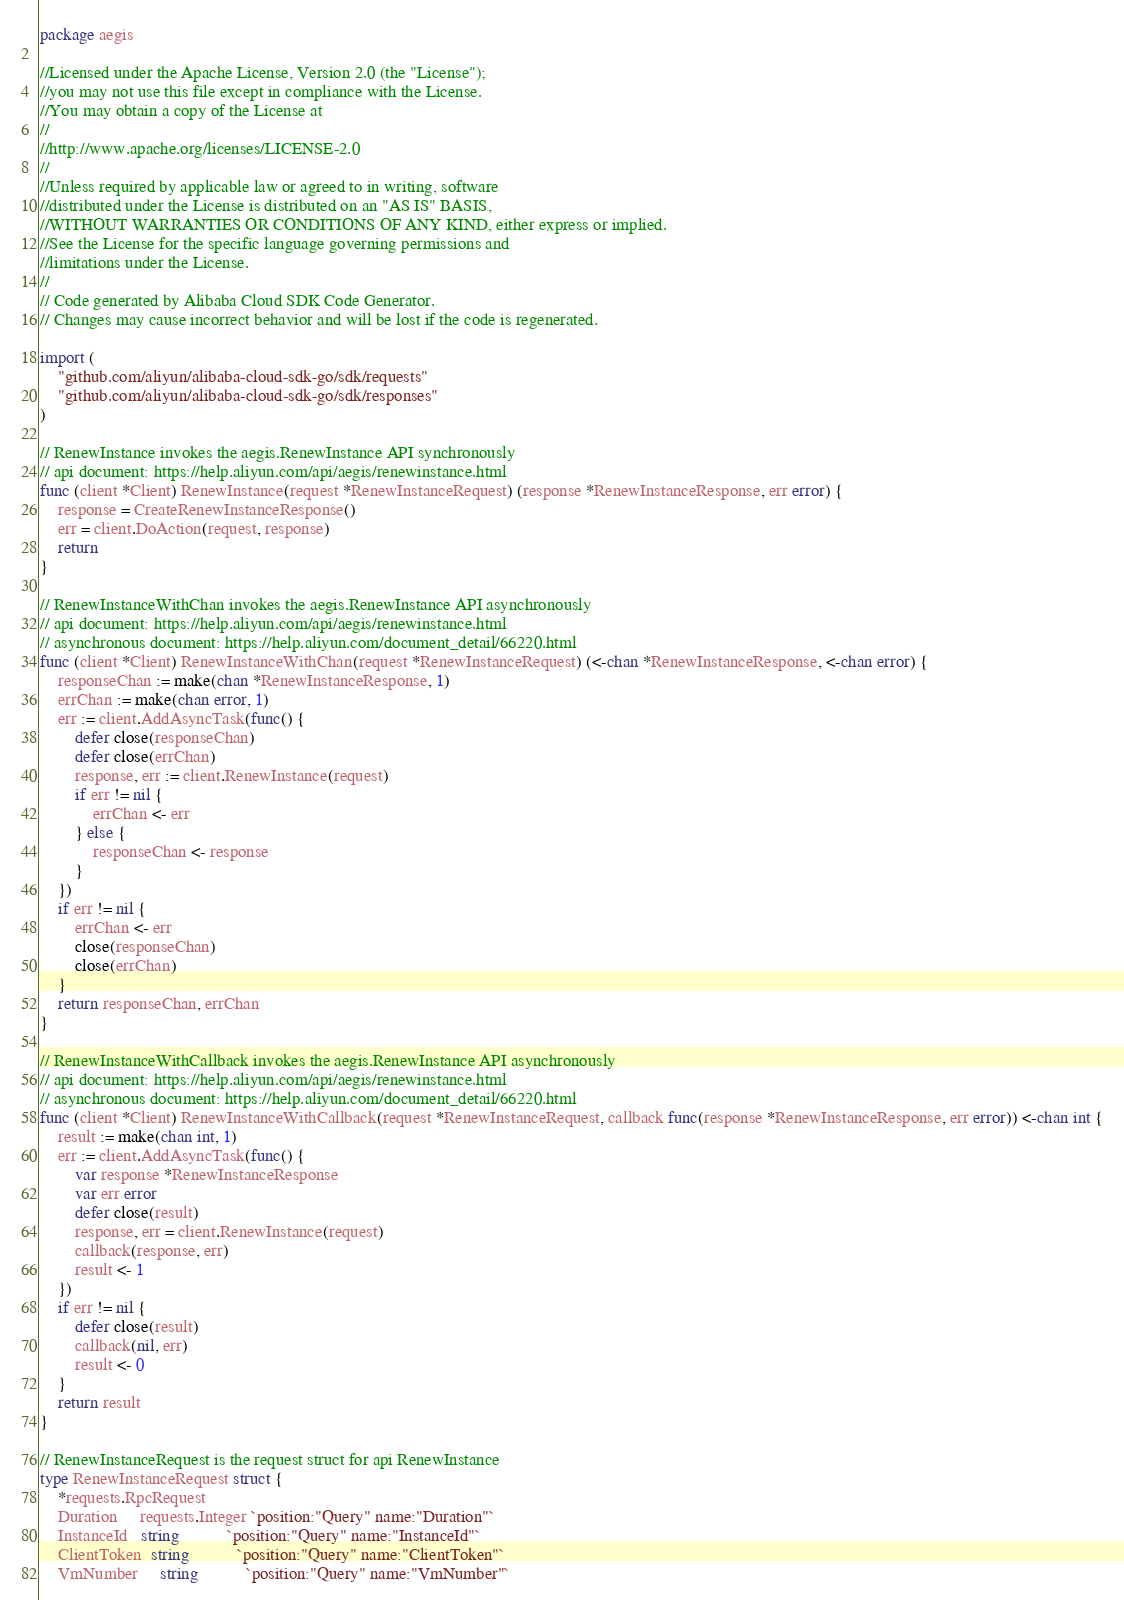Convert code to text. <code><loc_0><loc_0><loc_500><loc_500><_Go_>package aegis

//Licensed under the Apache License, Version 2.0 (the "License");
//you may not use this file except in compliance with the License.
//You may obtain a copy of the License at
//
//http://www.apache.org/licenses/LICENSE-2.0
//
//Unless required by applicable law or agreed to in writing, software
//distributed under the License is distributed on an "AS IS" BASIS,
//WITHOUT WARRANTIES OR CONDITIONS OF ANY KIND, either express or implied.
//See the License for the specific language governing permissions and
//limitations under the License.
//
// Code generated by Alibaba Cloud SDK Code Generator.
// Changes may cause incorrect behavior and will be lost if the code is regenerated.

import (
	"github.com/aliyun/alibaba-cloud-sdk-go/sdk/requests"
	"github.com/aliyun/alibaba-cloud-sdk-go/sdk/responses"
)

// RenewInstance invokes the aegis.RenewInstance API synchronously
// api document: https://help.aliyun.com/api/aegis/renewinstance.html
func (client *Client) RenewInstance(request *RenewInstanceRequest) (response *RenewInstanceResponse, err error) {
	response = CreateRenewInstanceResponse()
	err = client.DoAction(request, response)
	return
}

// RenewInstanceWithChan invokes the aegis.RenewInstance API asynchronously
// api document: https://help.aliyun.com/api/aegis/renewinstance.html
// asynchronous document: https://help.aliyun.com/document_detail/66220.html
func (client *Client) RenewInstanceWithChan(request *RenewInstanceRequest) (<-chan *RenewInstanceResponse, <-chan error) {
	responseChan := make(chan *RenewInstanceResponse, 1)
	errChan := make(chan error, 1)
	err := client.AddAsyncTask(func() {
		defer close(responseChan)
		defer close(errChan)
		response, err := client.RenewInstance(request)
		if err != nil {
			errChan <- err
		} else {
			responseChan <- response
		}
	})
	if err != nil {
		errChan <- err
		close(responseChan)
		close(errChan)
	}
	return responseChan, errChan
}

// RenewInstanceWithCallback invokes the aegis.RenewInstance API asynchronously
// api document: https://help.aliyun.com/api/aegis/renewinstance.html
// asynchronous document: https://help.aliyun.com/document_detail/66220.html
func (client *Client) RenewInstanceWithCallback(request *RenewInstanceRequest, callback func(response *RenewInstanceResponse, err error)) <-chan int {
	result := make(chan int, 1)
	err := client.AddAsyncTask(func() {
		var response *RenewInstanceResponse
		var err error
		defer close(result)
		response, err = client.RenewInstance(request)
		callback(response, err)
		result <- 1
	})
	if err != nil {
		defer close(result)
		callback(nil, err)
		result <- 0
	}
	return result
}

// RenewInstanceRequest is the request struct for api RenewInstance
type RenewInstanceRequest struct {
	*requests.RpcRequest
	Duration     requests.Integer `position:"Query" name:"Duration"`
	InstanceId   string           `position:"Query" name:"InstanceId"`
	ClientToken  string           `position:"Query" name:"ClientToken"`
	VmNumber     string           `position:"Query" name:"VmNumber"`</code> 